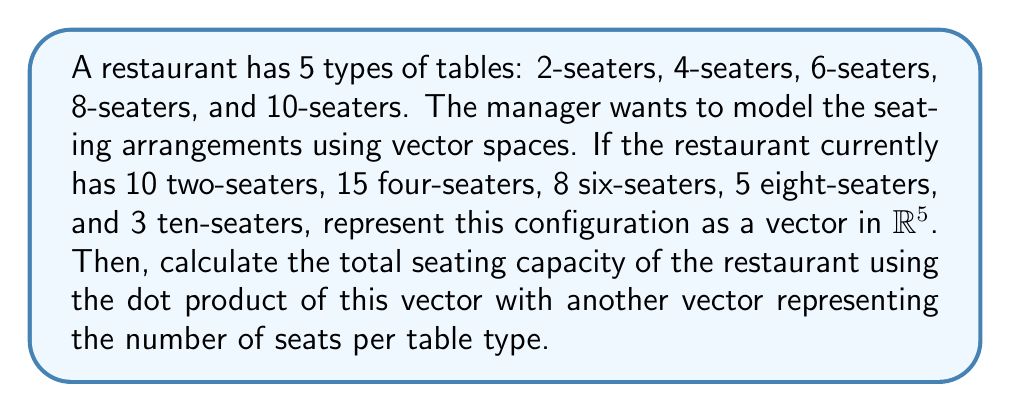Show me your answer to this math problem. Let's approach this step-by-step:

1) First, we need to define our vector space. In this case, we can use $\mathbb{R}^5$, where each dimension represents a type of table.

2) We can represent the current configuration of tables as a vector $\mathbf{v}$ in this space:

   $$\mathbf{v} = \begin{pmatrix} 10 \\ 15 \\ 8 \\ 5 \\ 3 \end{pmatrix}$$

   Where the components represent the number of 2-seaters, 4-seaters, 6-seaters, 8-seaters, and 10-seaters respectively.

3) Now, we need another vector $\mathbf{s}$ that represents the number of seats for each table type:

   $$\mathbf{s} = \begin{pmatrix} 2 \\ 4 \\ 6 \\ 8 \\ 10 \end{pmatrix}$$

4) To calculate the total seating capacity, we can use the dot product of these two vectors:

   $$\text{Total Capacity} = \mathbf{v} \cdot \mathbf{s} = \sum_{i=1}^5 v_i s_i$$

5) Let's calculate this:

   $$\begin{align*}
   \text{Total Capacity} &= (10 \times 2) + (15 \times 4) + (8 \times 6) + (5 \times 8) + (3 \times 10) \\
   &= 20 + 60 + 48 + 40 + 30 \\
   &= 198
   \end{align*}$$

Thus, the total seating capacity of the restaurant is 198 seats.
Answer: The vector representing the current table configuration is $\mathbf{v} = \begin{pmatrix} 10 \\ 15 \\ 8 \\ 5 \\ 3 \end{pmatrix}$, and the total seating capacity is 198 seats. 